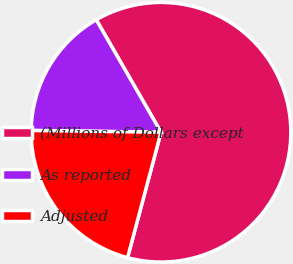Convert chart. <chart><loc_0><loc_0><loc_500><loc_500><pie_chart><fcel>(Millions of Dollars except<fcel>As reported<fcel>Adjusted<nl><fcel>62.47%<fcel>16.47%<fcel>21.07%<nl></chart> 